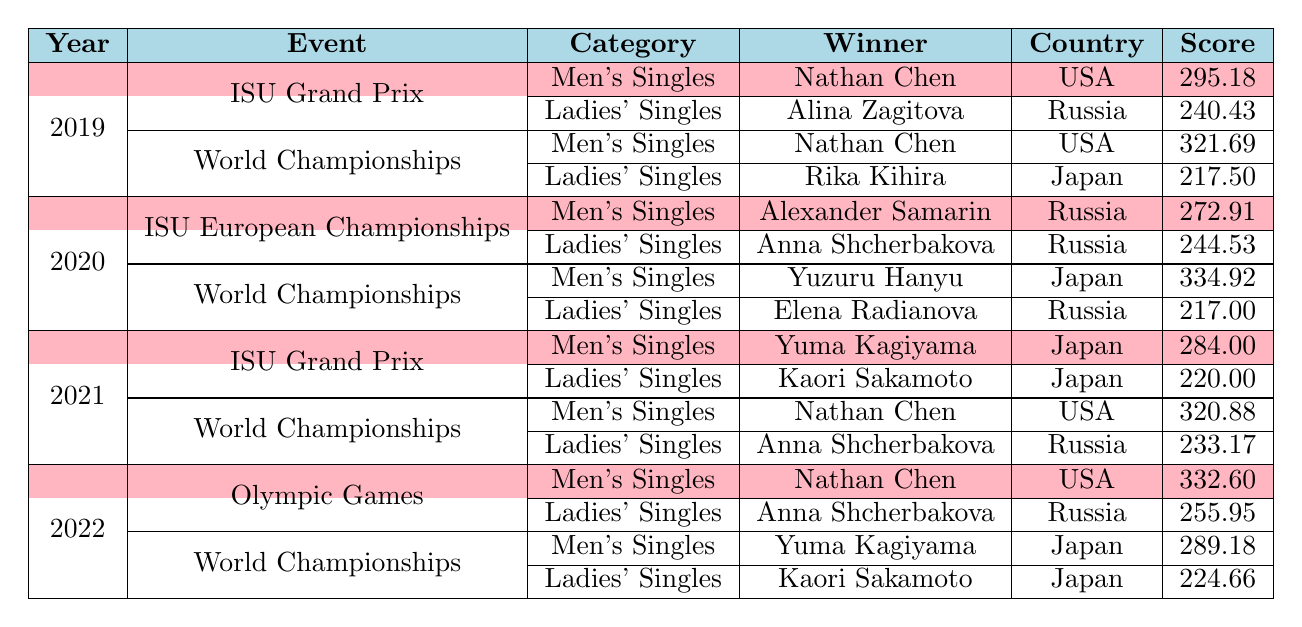What is the score of Nathan Chen in the 2022 Olympic Games? In the table, under the year 2022 and the event "Olympic Games," Nathan Chen is listed as the winner in the Men's Singles category with a score of 332.60.
Answer: 332.60 Who won the Ladies' Singles at the 2020 World Championships? The table shows that in the year 2020, during the World Championships in Ladies' Singles, Elena Radianova from Russia was the winner with a score of 217.00.
Answer: Elena Radianova Which year's ISU Grand Prix saw the highest score in Men's Singles, and what was that score? The table displays scores for Men's Singles at the ISU Grand Prix across several years. Nathan Chen's score in 2019 was 295.18, while Yuma Kagiyama's score in 2021 was 284.00. Since 295.18 is higher, 2019 had the highest score of 295.18.
Answer: 2019, 295.18 Was the winner of the Ladies' Singles at the 2022 Olympic Games from Japan? In the table, the data for the Ladies' Singles at the 2022 Olympic Games shows Anna Shcherbakova from Russia as the winner. Therefore, the statement is false.
Answer: No What was the average score for Men's Singles winners in the World Championships from 2019 to 2022? To find the average, we first sum up the scores: 321.69 (2019) + 334.92 (2020) + 320.88 (2021) + 289.18 (2022) = 1266.67. There are 4 events, so we divide 1266.67 by 4, which gives us 316.67.
Answer: 316.67 How many winners from Japan participated in the Ladies' Singles from 2019 to 2022? From the table, the winners in the Ladies' Singles were Alina Zagitova (2019), Rika Kihira (2019), Anna Shcherbakova (2020), Elena Radianova (2020), Kaori Sakamoto (2021), Anna Shcherbakova (2021), Anna Shcherbakova (2022), and Kaori Sakamoto (2022). Kaori Sakamoto and Anna Shcherbakova are the only winners from Japan, with 2 instances overall.
Answer: 2 Which event had the highest winner's score for Ladies' Singles, and who was the winner? The scores in the Ladies' Singles category show that Anna Shcherbakova scored 255.95 during the 2022 Olympic Games, which is higher than any other score listed. Therefore, the highest score was 255.95 from the 2022 Olympic Games, with Anna Shcherbakova as the winner.
Answer: 2022 Olympic Games, Anna Shcherbakova, 255.95 Identify the countries that won in Men's Singles during the World Championships? The table captures Men's Singles winners at World Championships for 2019 (USA), 2020 (Japan), 2021 (USA), and 2022 (Japan). This results in winners from the USA and Japan.
Answer: USA, Japan 